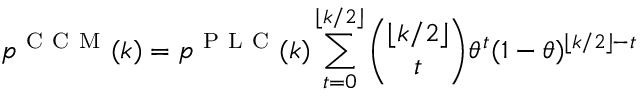Convert formula to latex. <formula><loc_0><loc_0><loc_500><loc_500>p ^ { C C M } ( k ) = p ^ { P L C } ( k ) \sum _ { t = 0 } ^ { \lfloor k / 2 \rfloor } \binom { \lfloor k / 2 \rfloor } { t } \theta ^ { t } ( 1 - \theta ) ^ { \lfloor k / 2 \rfloor - t }</formula> 